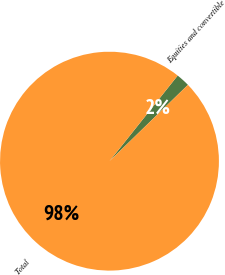Convert chart to OTSL. <chart><loc_0><loc_0><loc_500><loc_500><pie_chart><fcel>Equities and convertible<fcel>Total<nl><fcel>2.01%<fcel>97.99%<nl></chart> 